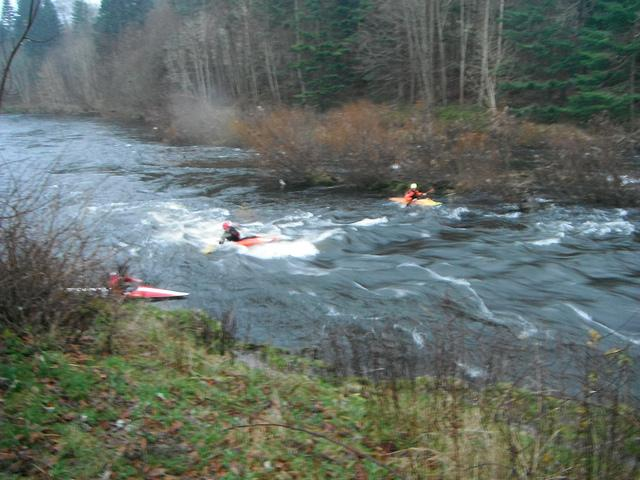Which direction are kayakers facing?

Choices:
A) upside down
B) down stream
C) bank wards
D) up river up river 